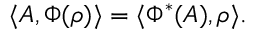<formula> <loc_0><loc_0><loc_500><loc_500>\langle A , \Phi ( \rho ) \rangle = \langle \Phi ^ { * } ( A ) , \rho \rangle .</formula> 